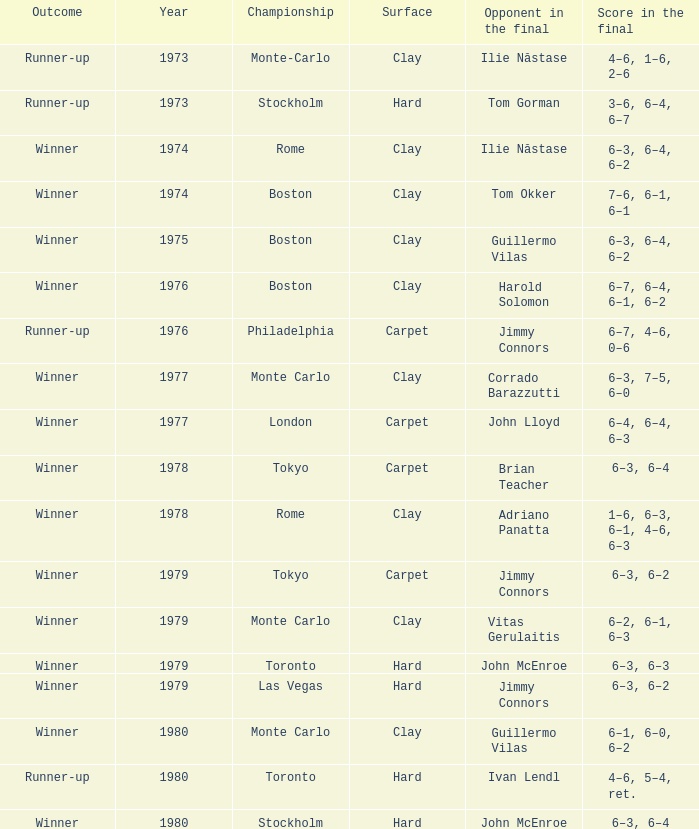Identify the year of clay for boston and guillermo vilas. 1975.0. Could you parse the entire table as a dict? {'header': ['Outcome', 'Year', 'Championship', 'Surface', 'Opponent in the final', 'Score in the final'], 'rows': [['Runner-up', '1973', 'Monte-Carlo', 'Clay', 'Ilie Năstase', '4–6, 1–6, 2–6'], ['Runner-up', '1973', 'Stockholm', 'Hard', 'Tom Gorman', '3–6, 6–4, 6–7'], ['Winner', '1974', 'Rome', 'Clay', 'Ilie Năstase', '6–3, 6–4, 6–2'], ['Winner', '1974', 'Boston', 'Clay', 'Tom Okker', '7–6, 6–1, 6–1'], ['Winner', '1975', 'Boston', 'Clay', 'Guillermo Vilas', '6–3, 6–4, 6–2'], ['Winner', '1976', 'Boston', 'Clay', 'Harold Solomon', '6–7, 6–4, 6–1, 6–2'], ['Runner-up', '1976', 'Philadelphia', 'Carpet', 'Jimmy Connors', '6–7, 4–6, 0–6'], ['Winner', '1977', 'Monte Carlo', 'Clay', 'Corrado Barazzutti', '6–3, 7–5, 6–0'], ['Winner', '1977', 'London', 'Carpet', 'John Lloyd', '6–4, 6–4, 6–3'], ['Winner', '1978', 'Tokyo', 'Carpet', 'Brian Teacher', '6–3, 6–4'], ['Winner', '1978', 'Rome', 'Clay', 'Adriano Panatta', '1–6, 6–3, 6–1, 4–6, 6–3'], ['Winner', '1979', 'Tokyo', 'Carpet', 'Jimmy Connors', '6–3, 6–2'], ['Winner', '1979', 'Monte Carlo', 'Clay', 'Vitas Gerulaitis', '6–2, 6–1, 6–3'], ['Winner', '1979', 'Toronto', 'Hard', 'John McEnroe', '6–3, 6–3'], ['Winner', '1979', 'Las Vegas', 'Hard', 'Jimmy Connors', '6–3, 6–2'], ['Winner', '1980', 'Monte Carlo', 'Clay', 'Guillermo Vilas', '6–1, 6–0, 6–2'], ['Runner-up', '1980', 'Toronto', 'Hard', 'Ivan Lendl', '4–6, 5–4, ret.'], ['Winner', '1980', 'Stockholm', 'Hard', 'John McEnroe', '6–3, 6–4']]} 